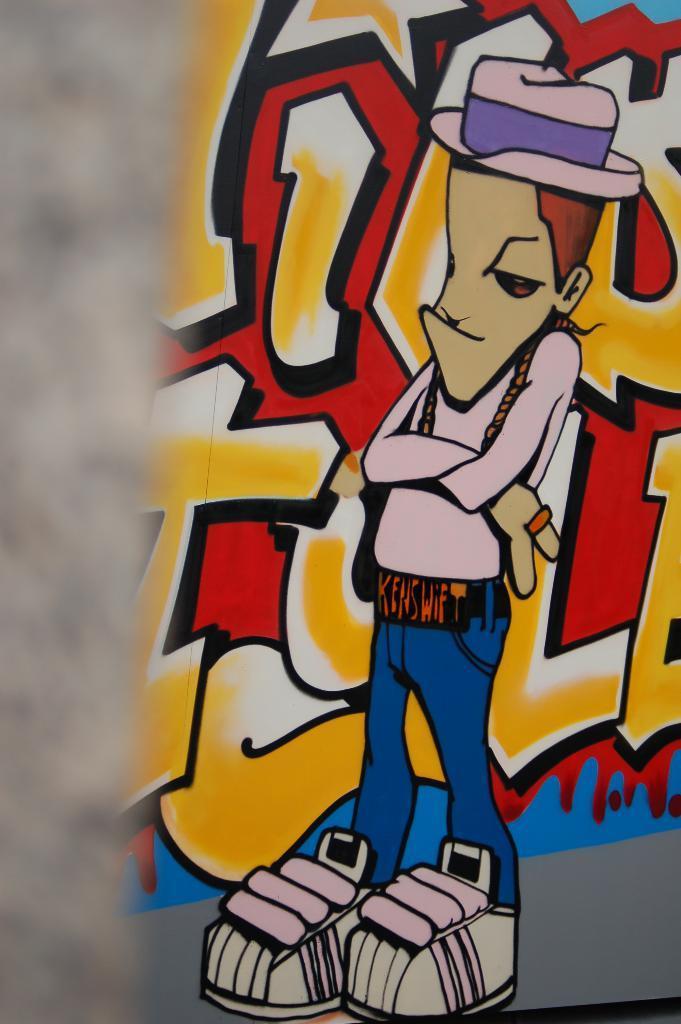Can you describe this image briefly? In this image we can see graffiti painting. 